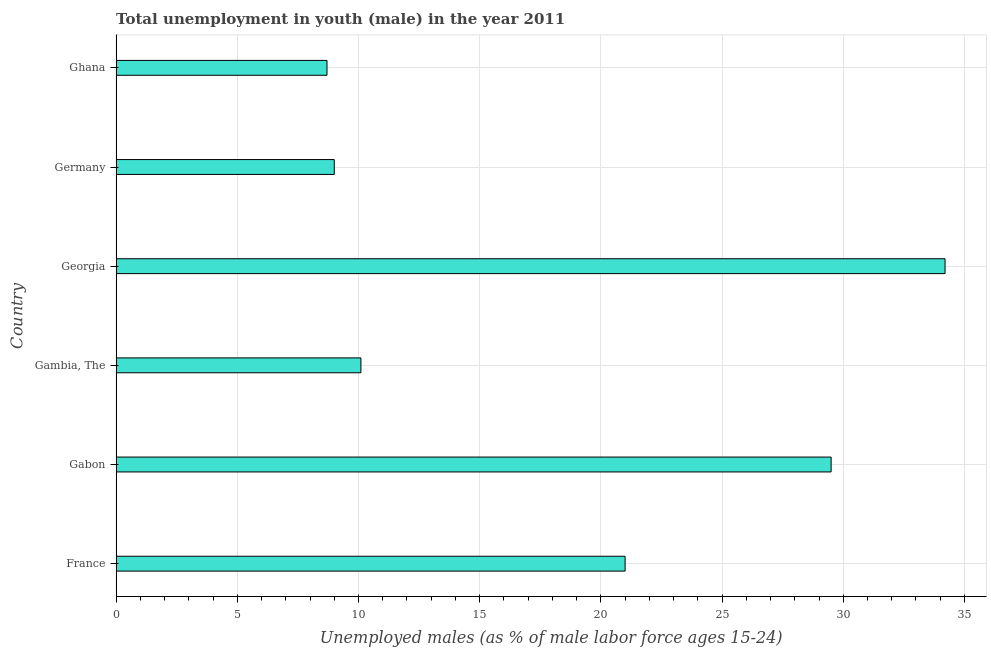Does the graph contain any zero values?
Offer a terse response. No. What is the title of the graph?
Offer a terse response. Total unemployment in youth (male) in the year 2011. What is the label or title of the X-axis?
Offer a very short reply. Unemployed males (as % of male labor force ages 15-24). What is the unemployed male youth population in Gabon?
Ensure brevity in your answer.  29.5. Across all countries, what is the maximum unemployed male youth population?
Provide a short and direct response. 34.2. Across all countries, what is the minimum unemployed male youth population?
Provide a short and direct response. 8.7. In which country was the unemployed male youth population maximum?
Ensure brevity in your answer.  Georgia. What is the sum of the unemployed male youth population?
Your answer should be very brief. 112.5. What is the difference between the unemployed male youth population in Georgia and Germany?
Ensure brevity in your answer.  25.2. What is the average unemployed male youth population per country?
Make the answer very short. 18.75. What is the median unemployed male youth population?
Provide a short and direct response. 15.55. In how many countries, is the unemployed male youth population greater than 17 %?
Give a very brief answer. 3. What is the ratio of the unemployed male youth population in Georgia to that in Germany?
Provide a short and direct response. 3.8. Is the sum of the unemployed male youth population in Gabon and Georgia greater than the maximum unemployed male youth population across all countries?
Give a very brief answer. Yes. What is the difference between the highest and the lowest unemployed male youth population?
Make the answer very short. 25.5. In how many countries, is the unemployed male youth population greater than the average unemployed male youth population taken over all countries?
Provide a short and direct response. 3. What is the Unemployed males (as % of male labor force ages 15-24) of Gabon?
Provide a short and direct response. 29.5. What is the Unemployed males (as % of male labor force ages 15-24) in Gambia, The?
Give a very brief answer. 10.1. What is the Unemployed males (as % of male labor force ages 15-24) in Georgia?
Give a very brief answer. 34.2. What is the Unemployed males (as % of male labor force ages 15-24) of Germany?
Ensure brevity in your answer.  9. What is the Unemployed males (as % of male labor force ages 15-24) of Ghana?
Make the answer very short. 8.7. What is the difference between the Unemployed males (as % of male labor force ages 15-24) in France and Gabon?
Provide a short and direct response. -8.5. What is the difference between the Unemployed males (as % of male labor force ages 15-24) in France and Georgia?
Provide a succinct answer. -13.2. What is the difference between the Unemployed males (as % of male labor force ages 15-24) in France and Ghana?
Your answer should be compact. 12.3. What is the difference between the Unemployed males (as % of male labor force ages 15-24) in Gabon and Gambia, The?
Keep it short and to the point. 19.4. What is the difference between the Unemployed males (as % of male labor force ages 15-24) in Gabon and Georgia?
Ensure brevity in your answer.  -4.7. What is the difference between the Unemployed males (as % of male labor force ages 15-24) in Gabon and Ghana?
Your answer should be compact. 20.8. What is the difference between the Unemployed males (as % of male labor force ages 15-24) in Gambia, The and Georgia?
Your answer should be very brief. -24.1. What is the difference between the Unemployed males (as % of male labor force ages 15-24) in Georgia and Germany?
Your answer should be very brief. 25.2. What is the difference between the Unemployed males (as % of male labor force ages 15-24) in Georgia and Ghana?
Give a very brief answer. 25.5. What is the difference between the Unemployed males (as % of male labor force ages 15-24) in Germany and Ghana?
Your answer should be compact. 0.3. What is the ratio of the Unemployed males (as % of male labor force ages 15-24) in France to that in Gabon?
Offer a terse response. 0.71. What is the ratio of the Unemployed males (as % of male labor force ages 15-24) in France to that in Gambia, The?
Your answer should be very brief. 2.08. What is the ratio of the Unemployed males (as % of male labor force ages 15-24) in France to that in Georgia?
Offer a very short reply. 0.61. What is the ratio of the Unemployed males (as % of male labor force ages 15-24) in France to that in Germany?
Your answer should be compact. 2.33. What is the ratio of the Unemployed males (as % of male labor force ages 15-24) in France to that in Ghana?
Your answer should be very brief. 2.41. What is the ratio of the Unemployed males (as % of male labor force ages 15-24) in Gabon to that in Gambia, The?
Offer a terse response. 2.92. What is the ratio of the Unemployed males (as % of male labor force ages 15-24) in Gabon to that in Georgia?
Offer a very short reply. 0.86. What is the ratio of the Unemployed males (as % of male labor force ages 15-24) in Gabon to that in Germany?
Make the answer very short. 3.28. What is the ratio of the Unemployed males (as % of male labor force ages 15-24) in Gabon to that in Ghana?
Offer a terse response. 3.39. What is the ratio of the Unemployed males (as % of male labor force ages 15-24) in Gambia, The to that in Georgia?
Provide a succinct answer. 0.29. What is the ratio of the Unemployed males (as % of male labor force ages 15-24) in Gambia, The to that in Germany?
Provide a succinct answer. 1.12. What is the ratio of the Unemployed males (as % of male labor force ages 15-24) in Gambia, The to that in Ghana?
Ensure brevity in your answer.  1.16. What is the ratio of the Unemployed males (as % of male labor force ages 15-24) in Georgia to that in Germany?
Your answer should be compact. 3.8. What is the ratio of the Unemployed males (as % of male labor force ages 15-24) in Georgia to that in Ghana?
Ensure brevity in your answer.  3.93. What is the ratio of the Unemployed males (as % of male labor force ages 15-24) in Germany to that in Ghana?
Your answer should be very brief. 1.03. 